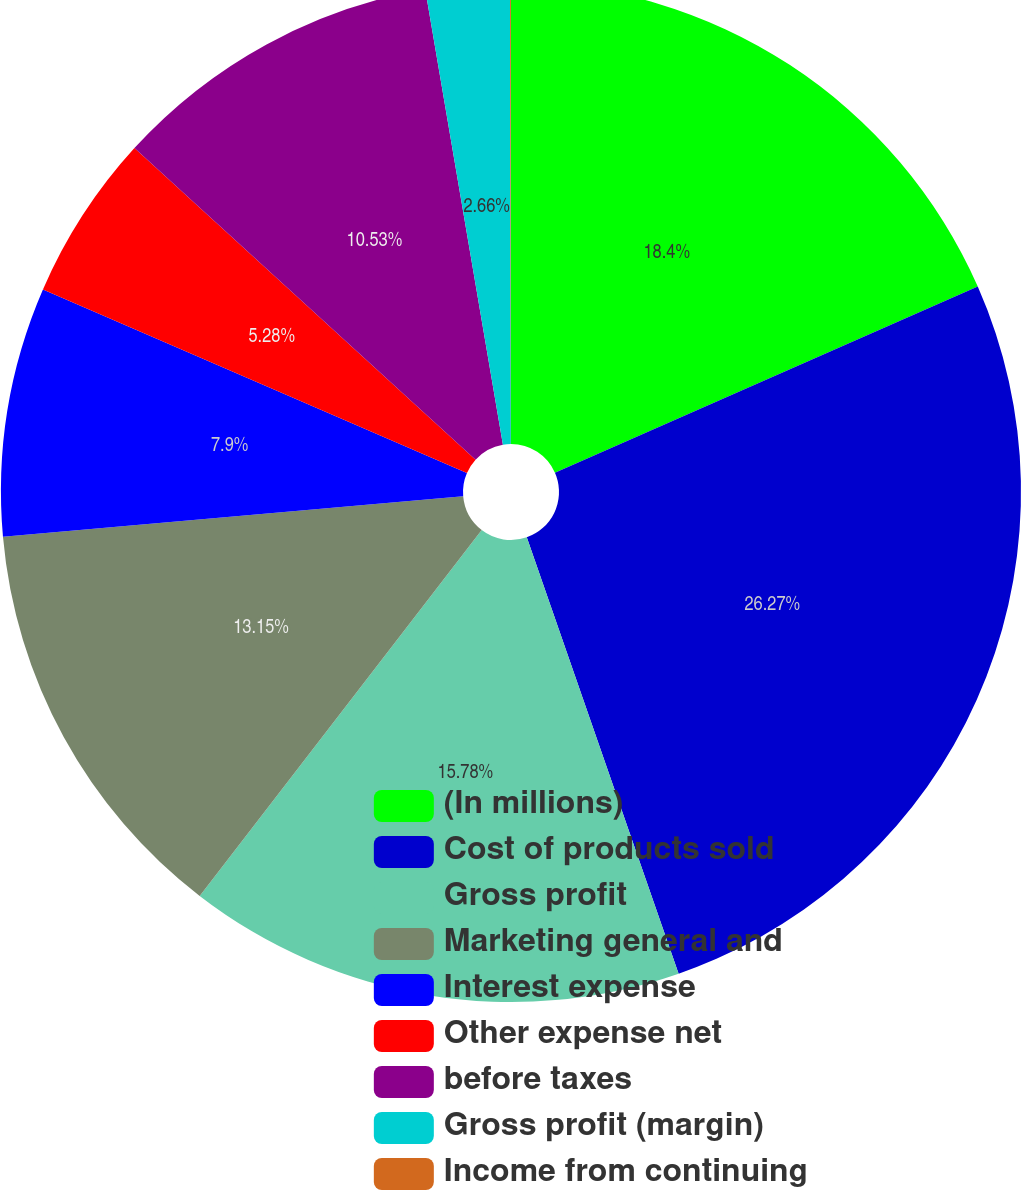<chart> <loc_0><loc_0><loc_500><loc_500><pie_chart><fcel>(In millions)<fcel>Cost of products sold<fcel>Gross profit<fcel>Marketing general and<fcel>Interest expense<fcel>Other expense net<fcel>before taxes<fcel>Gross profit (margin)<fcel>Income from continuing<nl><fcel>18.4%<fcel>26.27%<fcel>15.78%<fcel>13.15%<fcel>7.9%<fcel>5.28%<fcel>10.53%<fcel>2.66%<fcel>0.03%<nl></chart> 